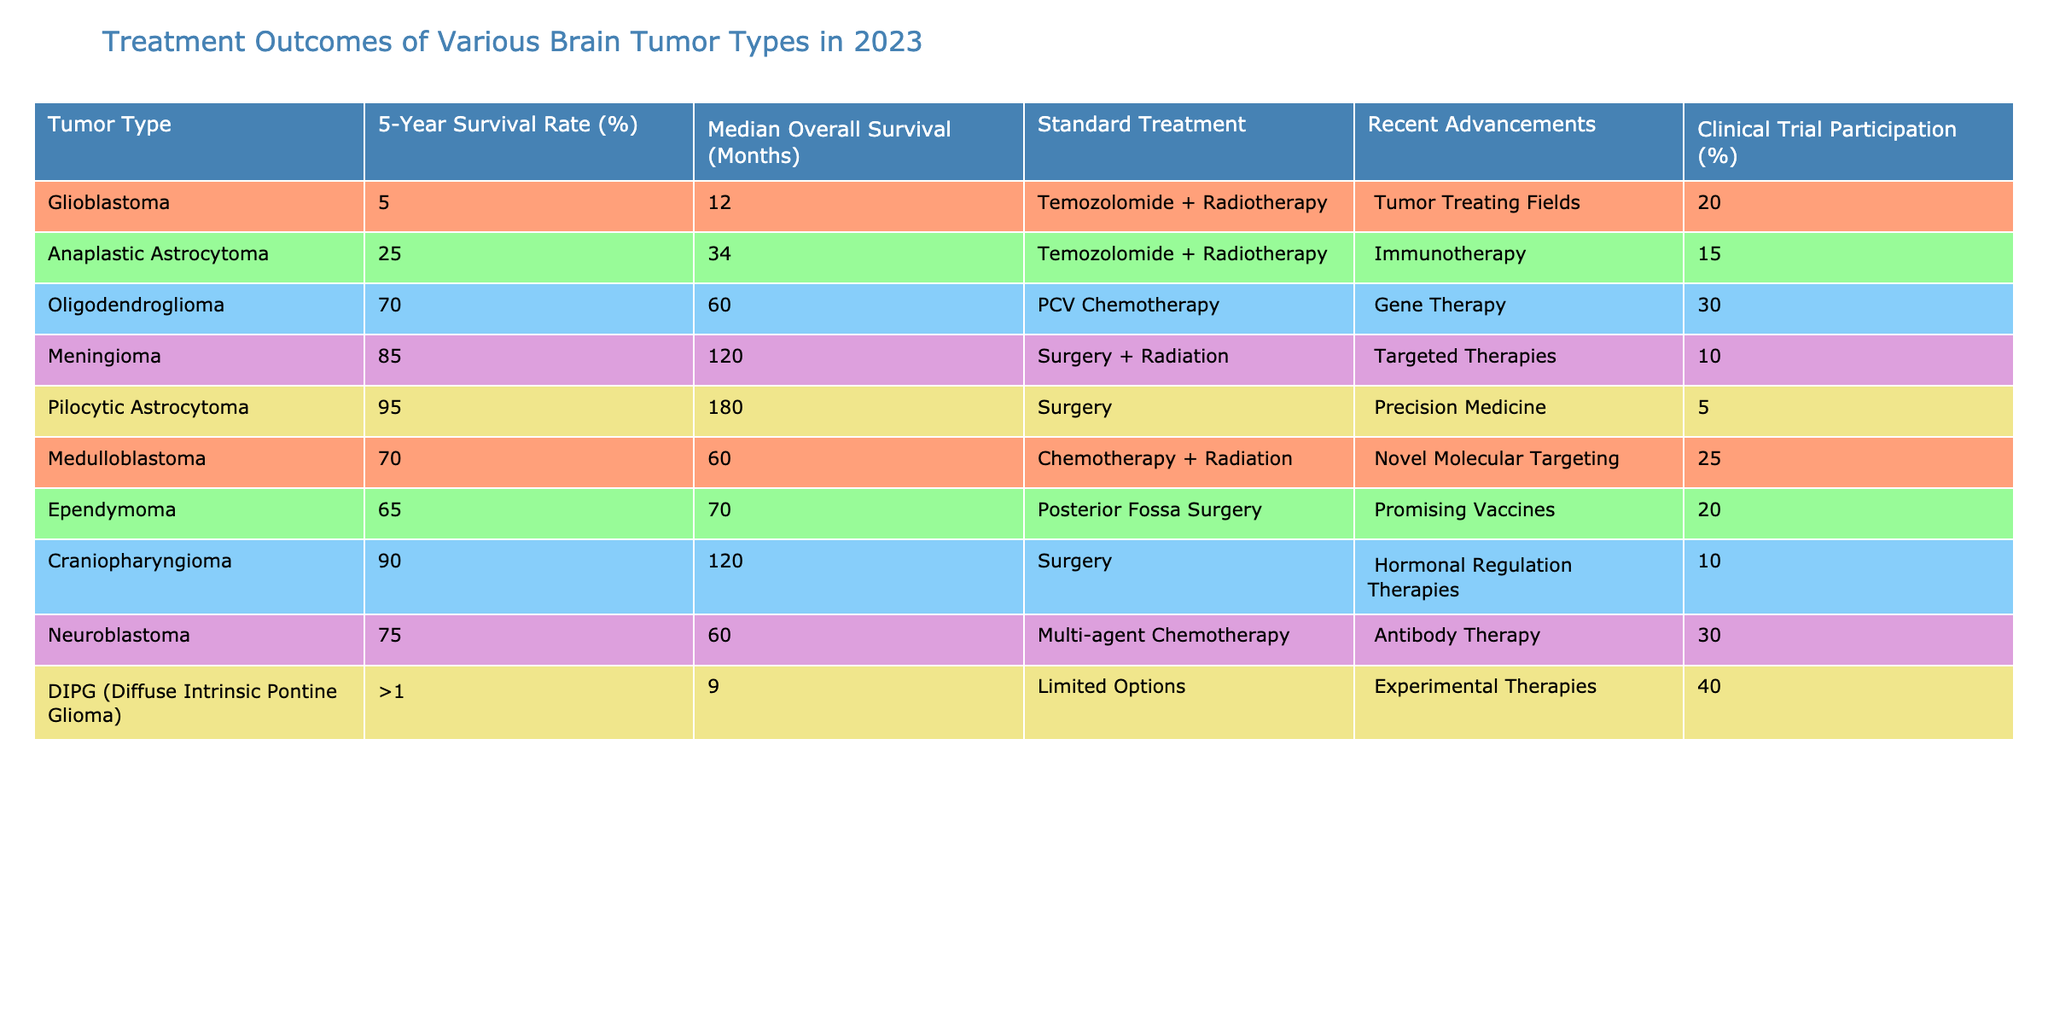What is the 5-year survival rate for Glioblastoma? The table states that the 5-year survival rate for Glioblastoma is 5%.
Answer: 5% What tumor type has the highest median overall survival? The median overall survival for Pilocytic Astrocytoma is 180 months, which is the highest value in the table.
Answer: Pilocytic Astrocytoma Which tumor type has the lowest clinical trial participation percentage? By reviewing the clinical trial participation percentages, Pilocytic Astrocytoma has the lowest at 5%.
Answer: 5% What is the difference in the 5-year survival rates between Anaplastic Astrocytoma and Oligodendroglioma? The 5-year survival rate for Anaplastic Astrocytoma is 25%, and for Oligodendroglioma, it is 70%. The difference is 70% - 25% = 45%.
Answer: 45% Which tumor type has both the highest 5-year survival rate and the lowest clinical trial participation? Pilocytic Astrocytoma has the highest 5-year survival rate at 95% but the lowest clinical trial participation at 5%.
Answer: Pilocytic Astrocytoma Is the statement "DIPG has a standard treatment of Temozolomide + Radiotherapy" true or false? The table indicates that DIPG has "Limited Options" for treatment, which means the statement is false.
Answer: False Calculate the average median overall survival of Medulloblastoma and Ependymoma. The median overall survival for Medulloblastoma is 60 months and for Ependymoma is 70 months. To find the average, we calculate (60 + 70) / 2 = 65 months.
Answer: 65 months What recent advancement is associated with Meningioma? The table shows that the recent advancement associated with Meningioma is "Targeted Therapies."
Answer: Targeted Therapies How many tumor types have a 5-year survival rate greater than 70%? There are three tumor types with a 5-year survival rate greater than 70%, which are Oligodendroglioma (70%), Meningioma (85%), and Pilocytic Astrocytoma (95%).
Answer: 3 What is the standard treatment for Neuroblastoma? The standard treatment listed for Neuroblastoma in the table is "Multi-agent Chemotherapy."
Answer: Multi-agent Chemotherapy 